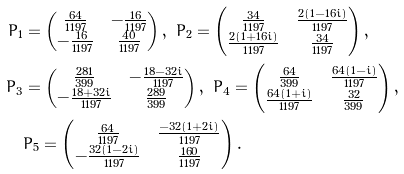<formula> <loc_0><loc_0><loc_500><loc_500>P _ { 1 } & = \begin{pmatrix} \frac { 6 4 } { 1 1 9 7 } & - \frac { 1 6 } { 1 1 9 7 } \\ - \frac { 1 6 } { 1 1 9 7 } & \frac { 4 0 } { 1 1 9 7 } \end{pmatrix} , \ P _ { 2 } = \begin{pmatrix} \frac { 3 4 } { 1 1 9 7 } & \frac { 2 ( 1 - 1 6 i ) } { 1 1 9 7 } \\ \frac { 2 ( 1 + 1 6 i ) } { 1 1 9 7 } & \frac { 3 4 } { 1 1 9 7 } \end{pmatrix} , \\ P _ { 3 } & = \begin{pmatrix} \frac { 2 8 1 } { 3 9 9 } & - \frac { 1 8 - 3 2 i } { 1 1 9 7 } \\ - \frac { 1 8 + 3 2 i } { 1 1 9 7 } & \frac { 2 8 9 } { 3 9 9 } \end{pmatrix} , \ P _ { 4 } = \begin{pmatrix} \frac { 6 4 } { 3 9 9 } & \frac { 6 4 ( 1 - i ) } { 1 1 9 7 } \\ \frac { 6 4 ( 1 + i ) } { 1 1 9 7 } & \frac { 3 2 } { 3 9 9 } \end{pmatrix} , \\ & P _ { 5 } = \begin{pmatrix} \frac { 6 4 } { 1 1 9 7 } & \frac { - 3 2 ( 1 + 2 i ) } { 1 1 9 7 } \\ - \frac { 3 2 ( 1 - 2 i ) } { 1 1 9 7 } & \frac { 1 6 0 } { 1 1 9 7 } \end{pmatrix} .</formula> 